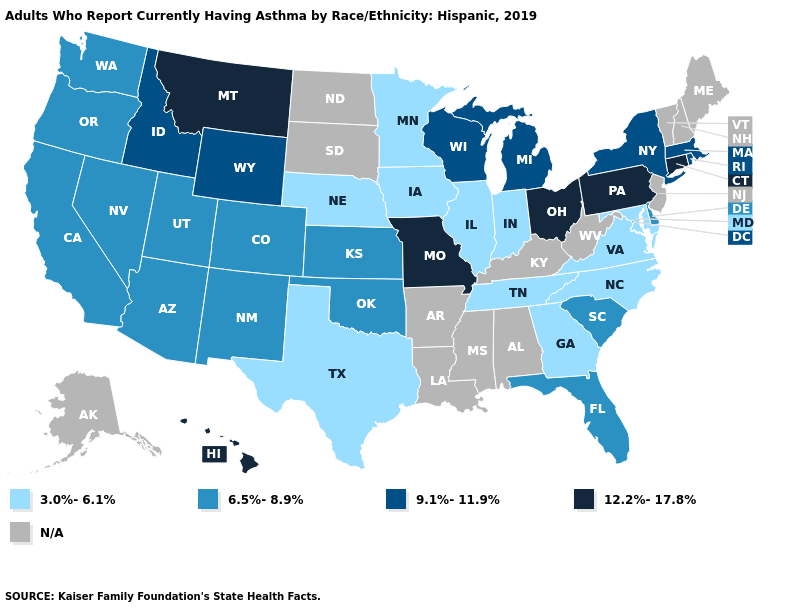Name the states that have a value in the range N/A?
Keep it brief. Alabama, Alaska, Arkansas, Kentucky, Louisiana, Maine, Mississippi, New Hampshire, New Jersey, North Dakota, South Dakota, Vermont, West Virginia. What is the highest value in the USA?
Answer briefly. 12.2%-17.8%. Does the first symbol in the legend represent the smallest category?
Give a very brief answer. Yes. Name the states that have a value in the range 9.1%-11.9%?
Write a very short answer. Idaho, Massachusetts, Michigan, New York, Rhode Island, Wisconsin, Wyoming. Does Connecticut have the highest value in the Northeast?
Answer briefly. Yes. What is the value of Louisiana?
Write a very short answer. N/A. Name the states that have a value in the range 3.0%-6.1%?
Give a very brief answer. Georgia, Illinois, Indiana, Iowa, Maryland, Minnesota, Nebraska, North Carolina, Tennessee, Texas, Virginia. Does Ohio have the highest value in the MidWest?
Quick response, please. Yes. Which states have the lowest value in the MidWest?
Give a very brief answer. Illinois, Indiana, Iowa, Minnesota, Nebraska. What is the lowest value in states that border New Jersey?
Be succinct. 6.5%-8.9%. Name the states that have a value in the range 3.0%-6.1%?
Quick response, please. Georgia, Illinois, Indiana, Iowa, Maryland, Minnesota, Nebraska, North Carolina, Tennessee, Texas, Virginia. What is the value of Kentucky?
Be succinct. N/A. Does Connecticut have the highest value in the Northeast?
Give a very brief answer. Yes. 